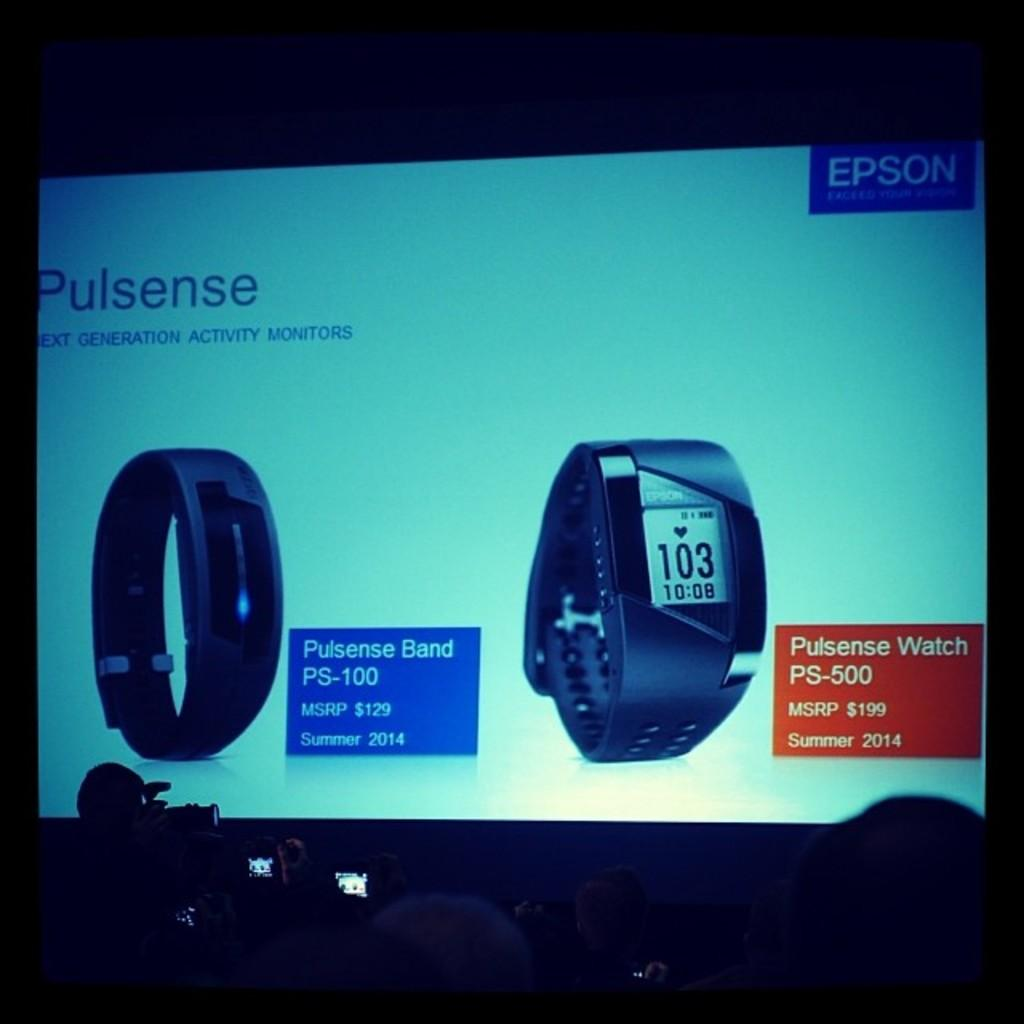<image>
Present a compact description of the photo's key features. A projection screen displaying two new activity monitors 